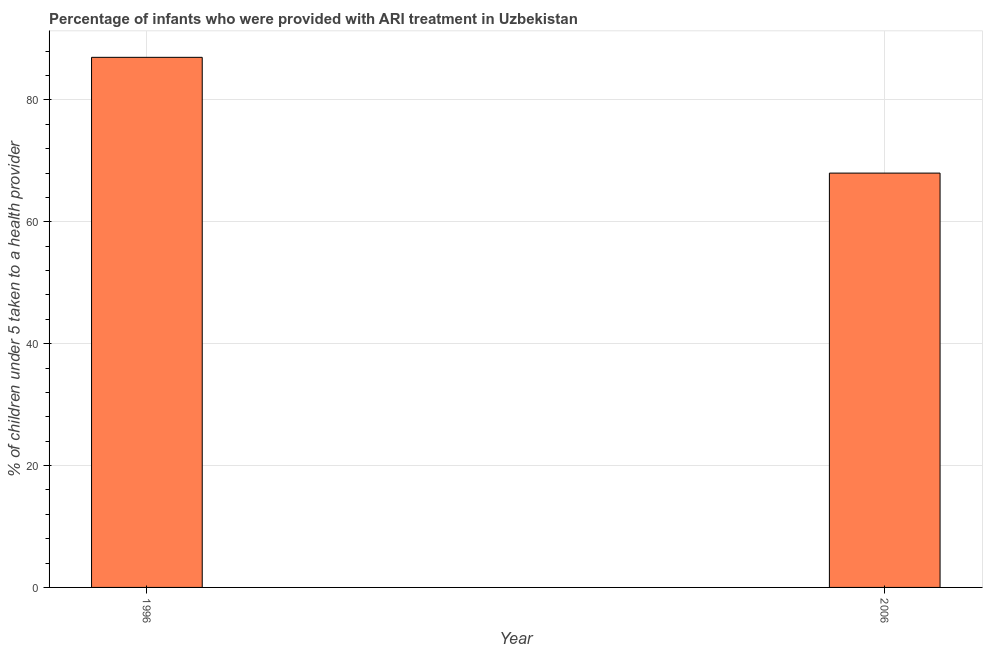Does the graph contain any zero values?
Your answer should be compact. No. Does the graph contain grids?
Your answer should be compact. Yes. What is the title of the graph?
Provide a short and direct response. Percentage of infants who were provided with ARI treatment in Uzbekistan. What is the label or title of the X-axis?
Give a very brief answer. Year. What is the label or title of the Y-axis?
Provide a short and direct response. % of children under 5 taken to a health provider. What is the percentage of children who were provided with ari treatment in 1996?
Keep it short and to the point. 87. Across all years, what is the maximum percentage of children who were provided with ari treatment?
Offer a very short reply. 87. In which year was the percentage of children who were provided with ari treatment maximum?
Your answer should be very brief. 1996. What is the sum of the percentage of children who were provided with ari treatment?
Your answer should be compact. 155. What is the median percentage of children who were provided with ari treatment?
Provide a short and direct response. 77.5. In how many years, is the percentage of children who were provided with ari treatment greater than 60 %?
Your answer should be very brief. 2. What is the ratio of the percentage of children who were provided with ari treatment in 1996 to that in 2006?
Ensure brevity in your answer.  1.28. Is the percentage of children who were provided with ari treatment in 1996 less than that in 2006?
Keep it short and to the point. No. In how many years, is the percentage of children who were provided with ari treatment greater than the average percentage of children who were provided with ari treatment taken over all years?
Ensure brevity in your answer.  1. Are all the bars in the graph horizontal?
Provide a succinct answer. No. What is the ratio of the % of children under 5 taken to a health provider in 1996 to that in 2006?
Provide a succinct answer. 1.28. 